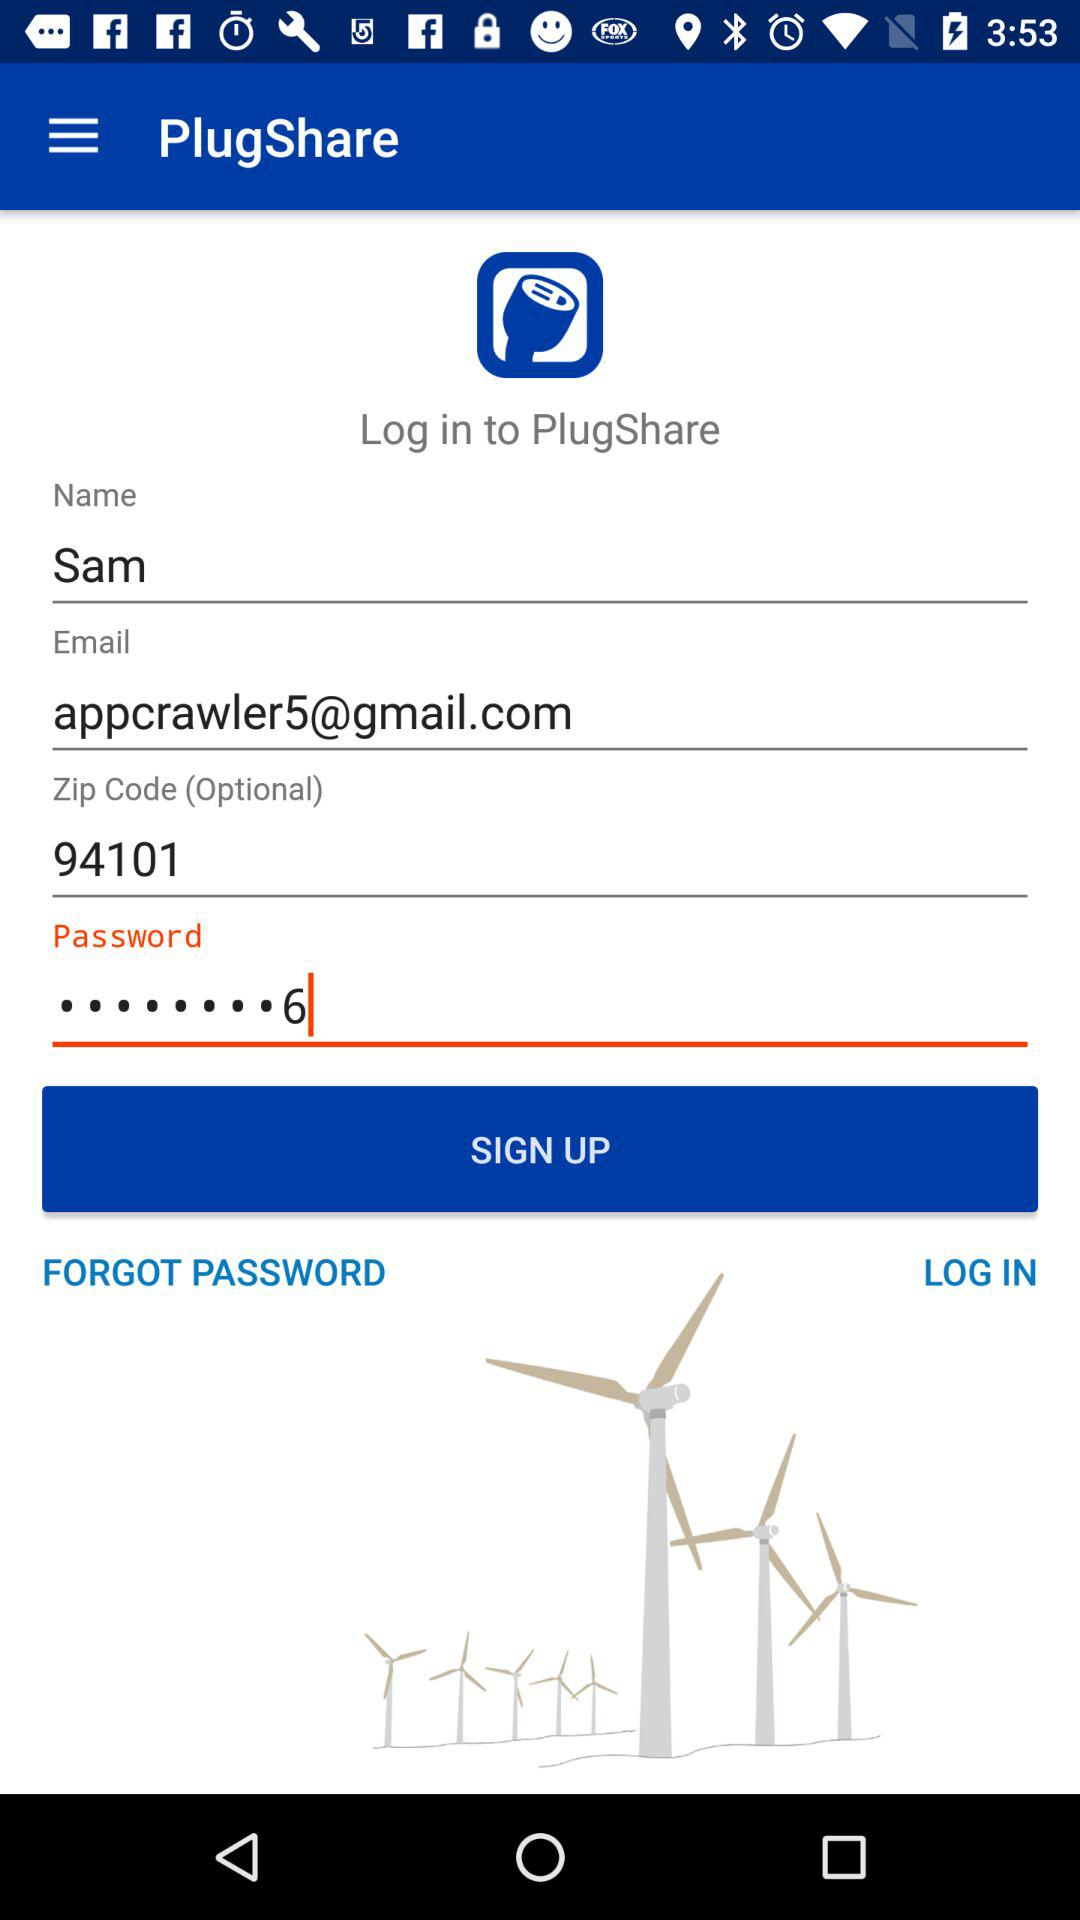What code is 94101? It is a zip code. 